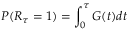<formula> <loc_0><loc_0><loc_500><loc_500>P ( R _ { \tau } = 1 ) = \int _ { 0 } ^ { \tau } G ( t ) d t</formula> 